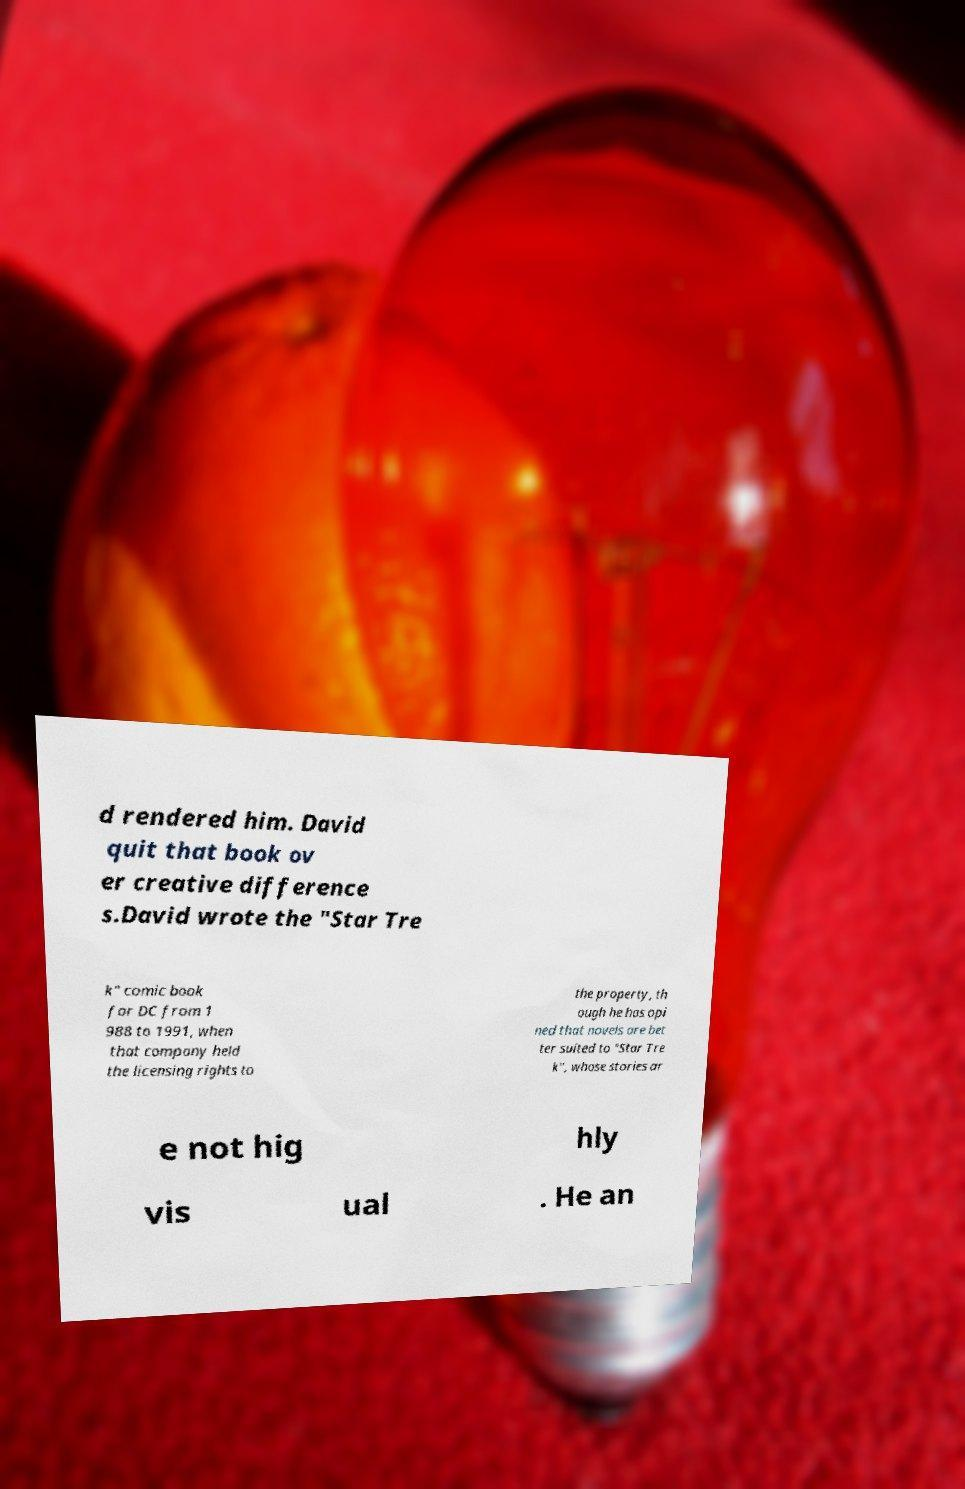What messages or text are displayed in this image? I need them in a readable, typed format. d rendered him. David quit that book ov er creative difference s.David wrote the "Star Tre k" comic book for DC from 1 988 to 1991, when that company held the licensing rights to the property, th ough he has opi ned that novels are bet ter suited to "Star Tre k", whose stories ar e not hig hly vis ual . He an 